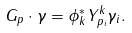<formula> <loc_0><loc_0><loc_500><loc_500>G _ { p } \cdot \gamma = \phi ^ { * } _ { k } Y ^ { k } _ { p _ { i } } \gamma _ { i } .</formula> 